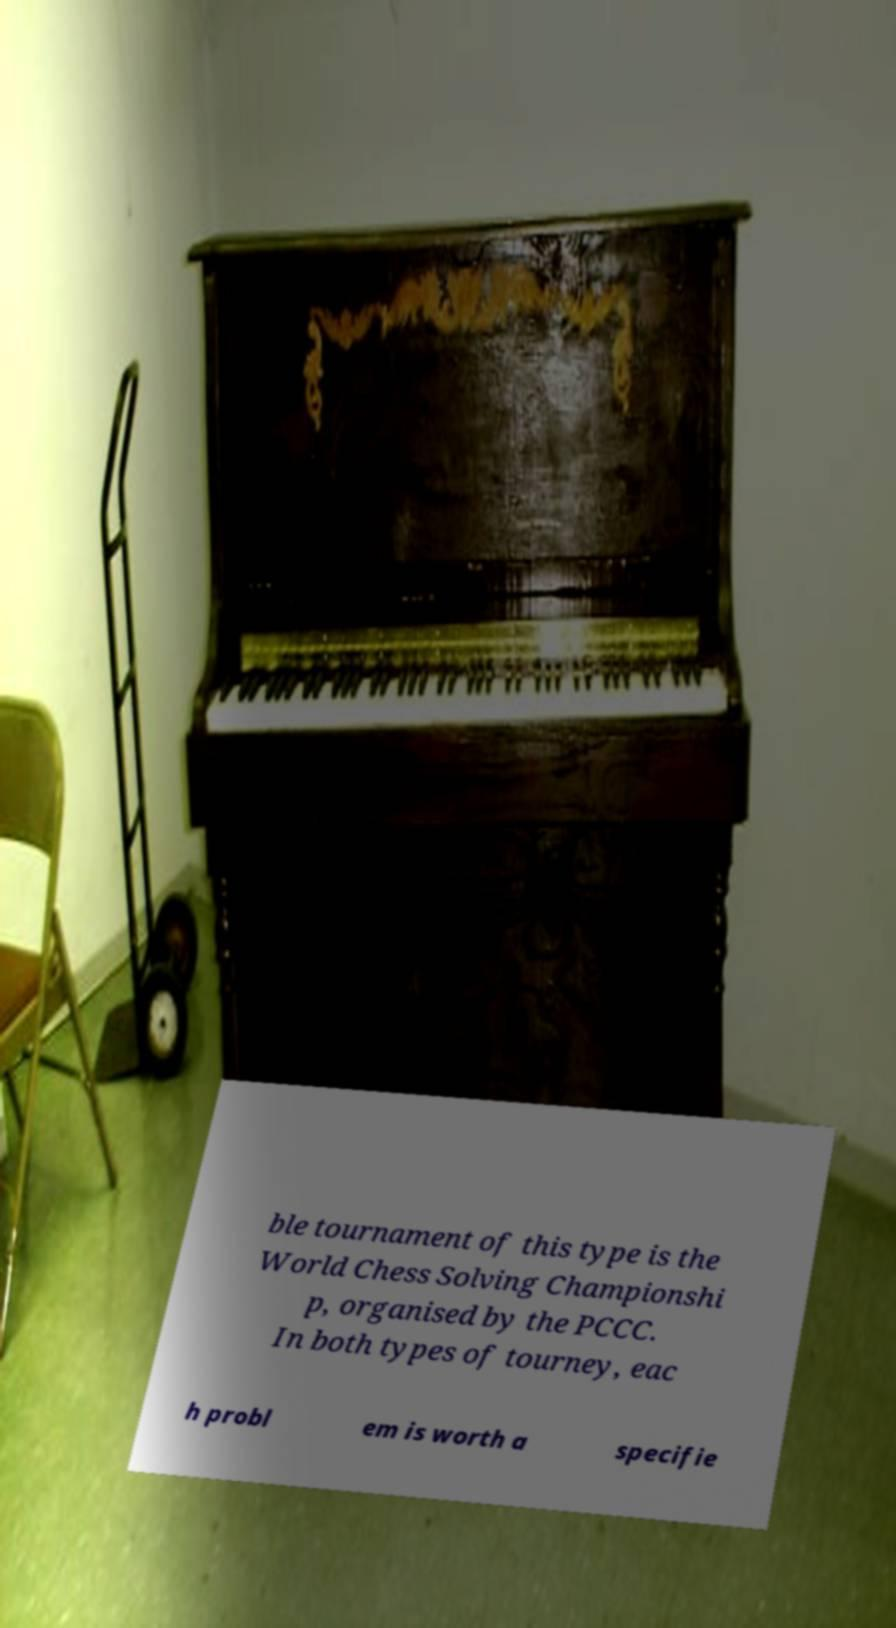I need the written content from this picture converted into text. Can you do that? ble tournament of this type is the World Chess Solving Championshi p, organised by the PCCC. In both types of tourney, eac h probl em is worth a specifie 